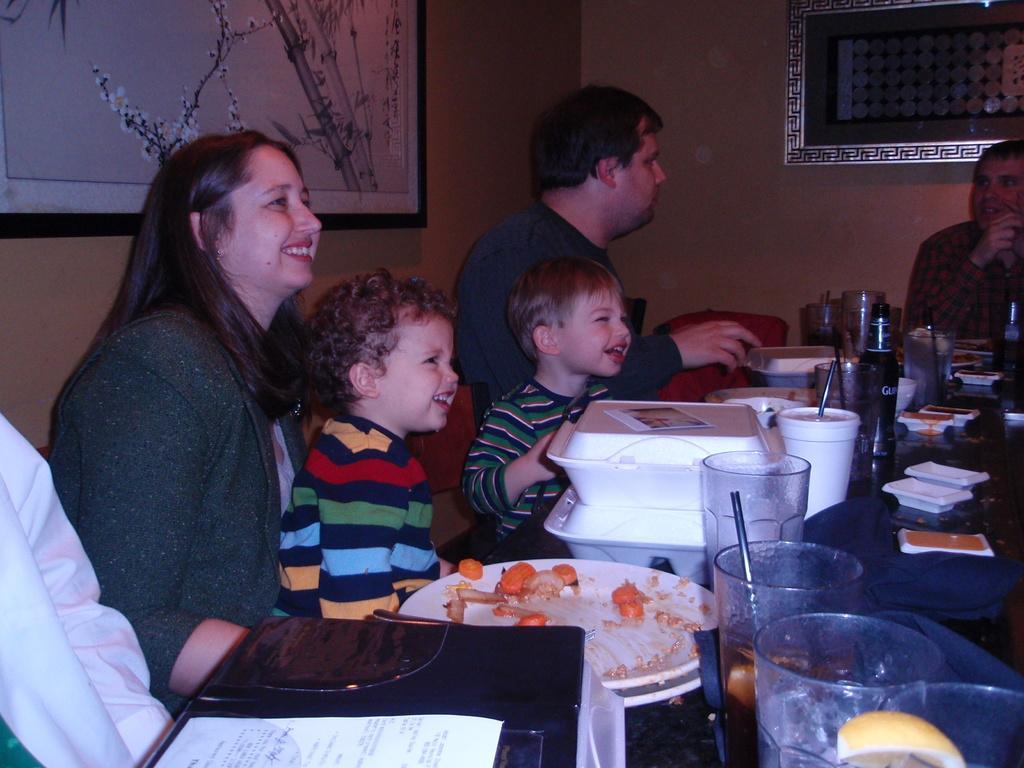Can you describe this image briefly? There are many persons sitting. And there are two small kids. And there is a table. On the table there are many glasses, boxes, plates, food items, paper. In the background there is a wall. On the wall there is a picture with photo frame. 